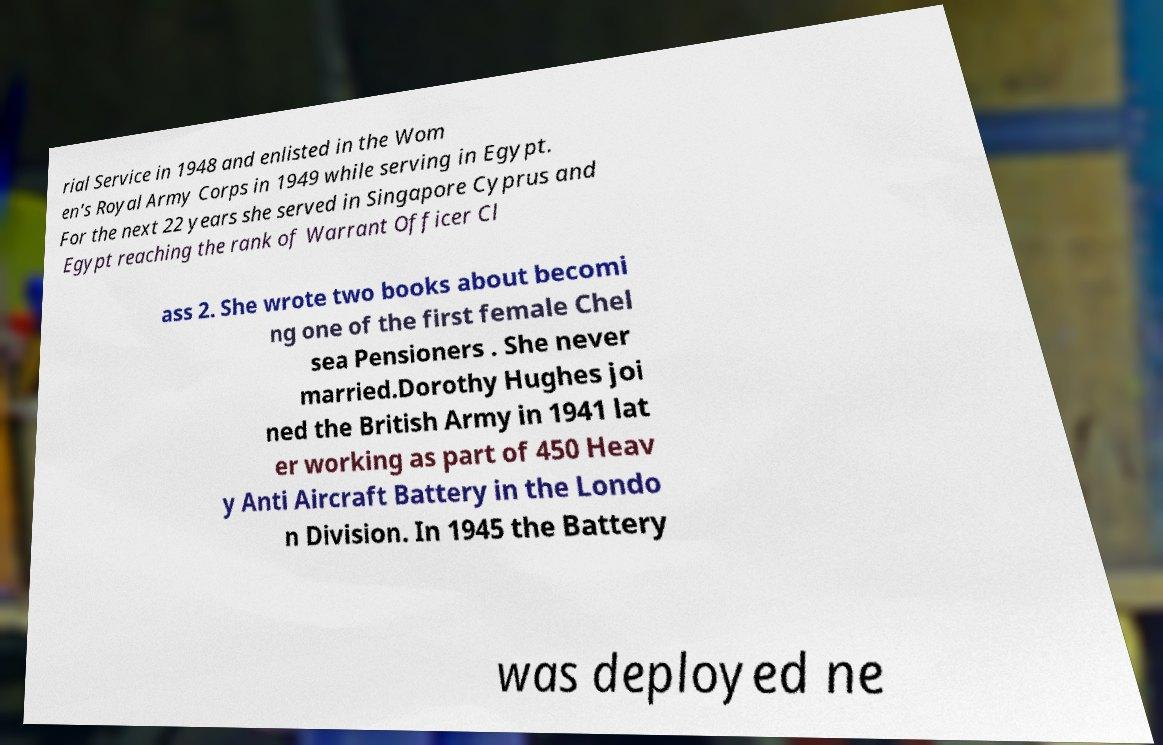What messages or text are displayed in this image? I need them in a readable, typed format. rial Service in 1948 and enlisted in the Wom en's Royal Army Corps in 1949 while serving in Egypt. For the next 22 years she served in Singapore Cyprus and Egypt reaching the rank of Warrant Officer Cl ass 2. She wrote two books about becomi ng one of the first female Chel sea Pensioners . She never married.Dorothy Hughes joi ned the British Army in 1941 lat er working as part of 450 Heav y Anti Aircraft Battery in the Londo n Division. In 1945 the Battery was deployed ne 